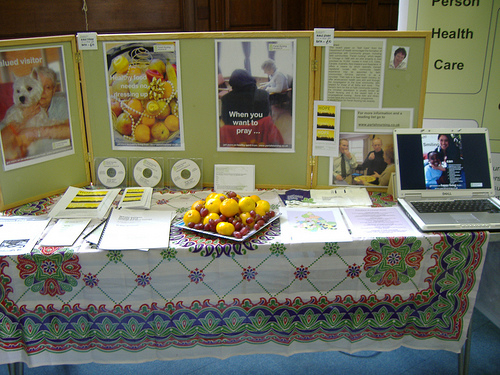<image>
Is there a fruits on the table? Yes. Looking at the image, I can see the fruits is positioned on top of the table, with the table providing support. Is there a girl in the laptop? Yes. The girl is contained within or inside the laptop, showing a containment relationship. 